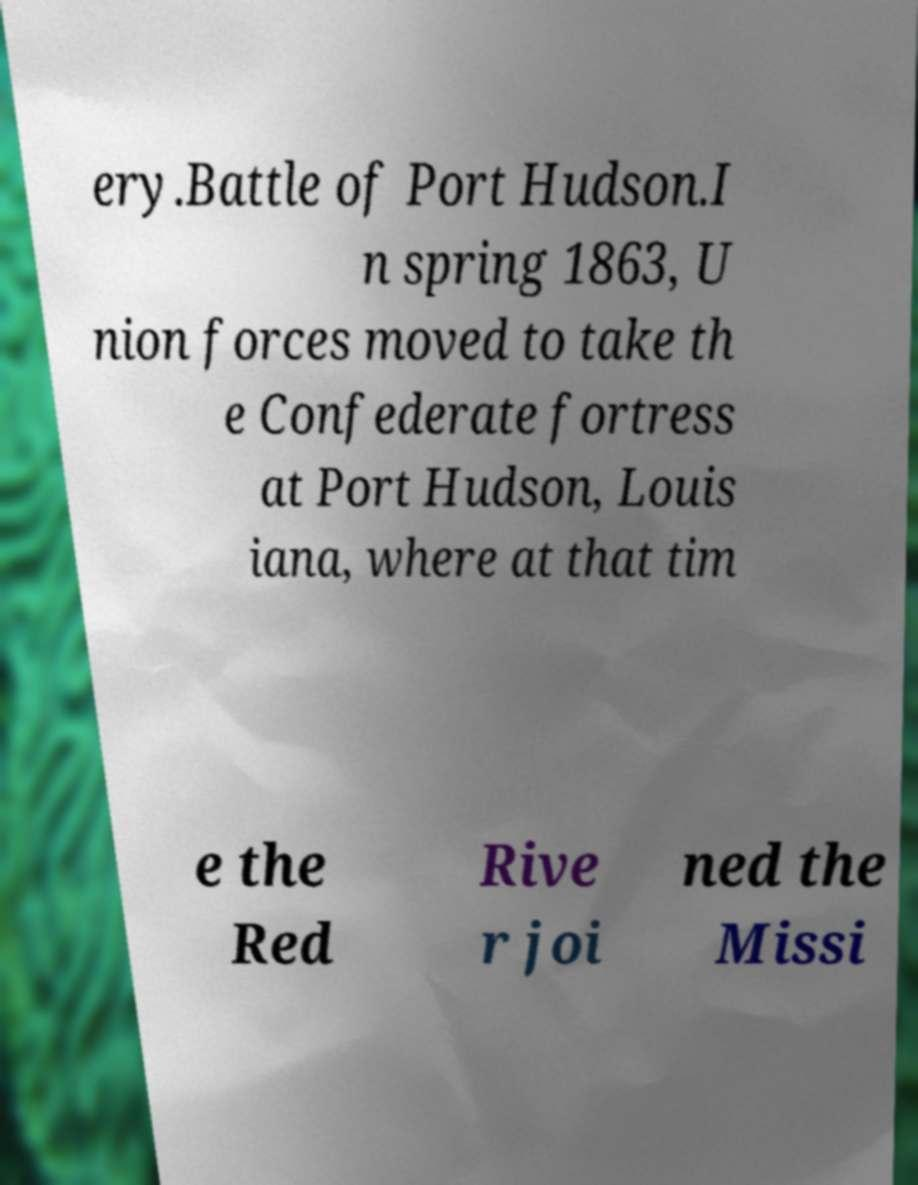Can you accurately transcribe the text from the provided image for me? ery.Battle of Port Hudson.I n spring 1863, U nion forces moved to take th e Confederate fortress at Port Hudson, Louis iana, where at that tim e the Red Rive r joi ned the Missi 